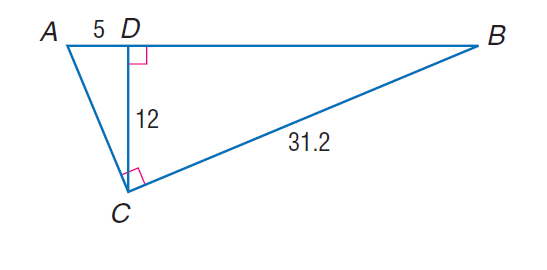Answer the mathemtical geometry problem and directly provide the correct option letter.
Question: Find the perimeter of the \triangle A B C, if \triangle A B C \sim \triangle C B D, A D = 5, C D = 12, and B C = 31.2.
Choices: A: 32.5 B: 72 C: 78 D: 187.2 C 